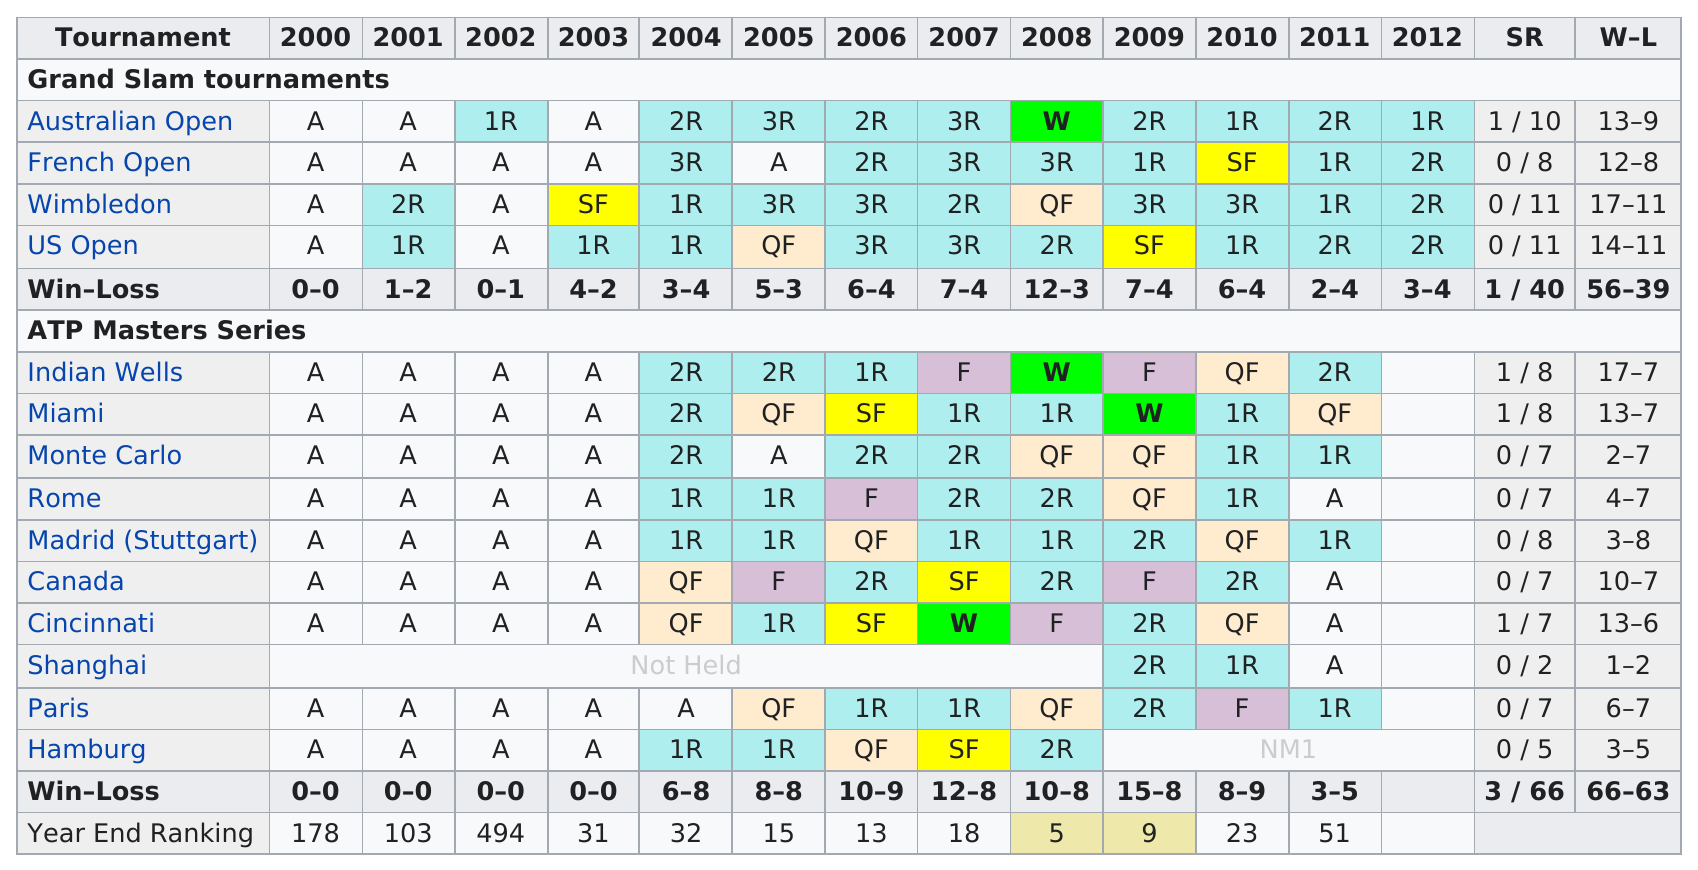Identify some key points in this picture. The year 2002 was the best year-end ranking in history. The total number of wins is 122. 